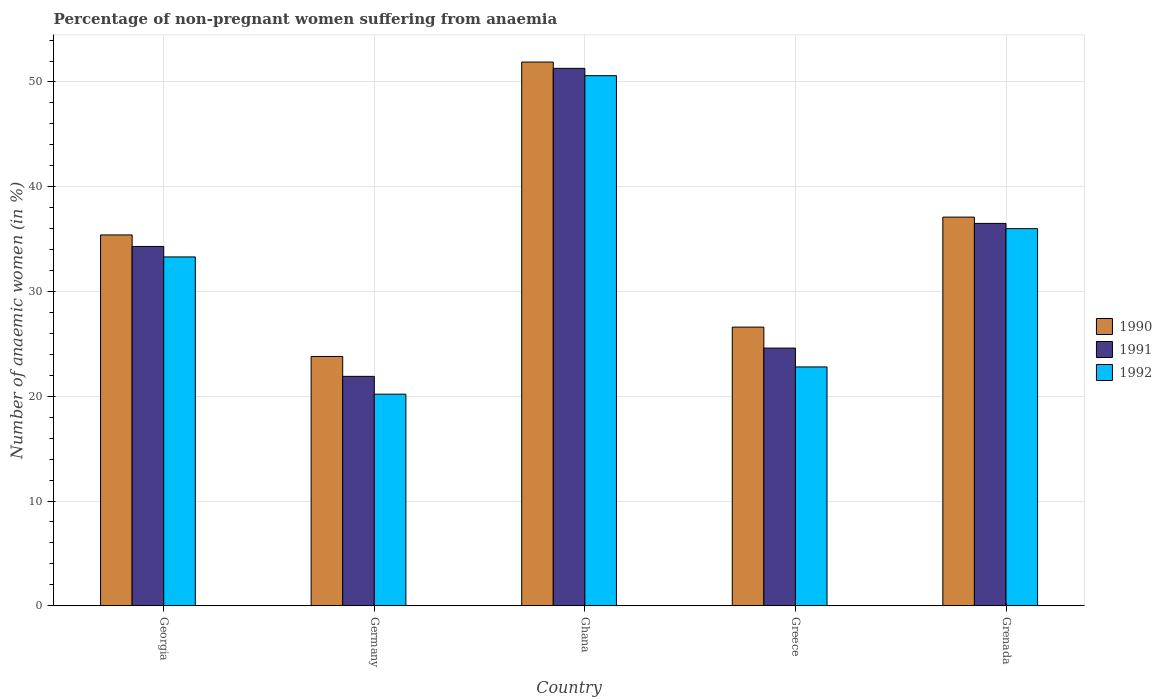How many different coloured bars are there?
Offer a very short reply. 3. How many groups of bars are there?
Your answer should be compact. 5. Are the number of bars on each tick of the X-axis equal?
Ensure brevity in your answer.  Yes. How many bars are there on the 1st tick from the left?
Your response must be concise. 3. How many bars are there on the 2nd tick from the right?
Make the answer very short. 3. In how many cases, is the number of bars for a given country not equal to the number of legend labels?
Your answer should be compact. 0. What is the percentage of non-pregnant women suffering from anaemia in 1991 in Ghana?
Provide a short and direct response. 51.3. Across all countries, what is the maximum percentage of non-pregnant women suffering from anaemia in 1992?
Give a very brief answer. 50.6. Across all countries, what is the minimum percentage of non-pregnant women suffering from anaemia in 1990?
Ensure brevity in your answer.  23.8. In which country was the percentage of non-pregnant women suffering from anaemia in 1991 maximum?
Your answer should be compact. Ghana. In which country was the percentage of non-pregnant women suffering from anaemia in 1992 minimum?
Make the answer very short. Germany. What is the total percentage of non-pregnant women suffering from anaemia in 1992 in the graph?
Your answer should be compact. 162.9. What is the difference between the percentage of non-pregnant women suffering from anaemia in 1992 in Germany and that in Grenada?
Your answer should be very brief. -15.8. What is the difference between the percentage of non-pregnant women suffering from anaemia in 1990 in Georgia and the percentage of non-pregnant women suffering from anaemia in 1992 in Ghana?
Provide a short and direct response. -15.2. What is the average percentage of non-pregnant women suffering from anaemia in 1990 per country?
Provide a short and direct response. 34.96. What is the difference between the percentage of non-pregnant women suffering from anaemia of/in 1991 and percentage of non-pregnant women suffering from anaemia of/in 1992 in Grenada?
Your answer should be compact. 0.5. In how many countries, is the percentage of non-pregnant women suffering from anaemia in 1992 greater than 14 %?
Offer a very short reply. 5. What is the ratio of the percentage of non-pregnant women suffering from anaemia in 1990 in Georgia to that in Grenada?
Your answer should be compact. 0.95. What is the difference between the highest and the second highest percentage of non-pregnant women suffering from anaemia in 1991?
Make the answer very short. -17. What is the difference between the highest and the lowest percentage of non-pregnant women suffering from anaemia in 1990?
Keep it short and to the point. 28.1. In how many countries, is the percentage of non-pregnant women suffering from anaemia in 1992 greater than the average percentage of non-pregnant women suffering from anaemia in 1992 taken over all countries?
Offer a very short reply. 3. Is the sum of the percentage of non-pregnant women suffering from anaemia in 1992 in Georgia and Grenada greater than the maximum percentage of non-pregnant women suffering from anaemia in 1991 across all countries?
Your answer should be very brief. Yes. What does the 2nd bar from the right in Georgia represents?
Your response must be concise. 1991. Are all the bars in the graph horizontal?
Your response must be concise. No. Are the values on the major ticks of Y-axis written in scientific E-notation?
Provide a short and direct response. No. Does the graph contain grids?
Provide a short and direct response. Yes. Where does the legend appear in the graph?
Provide a succinct answer. Center right. How are the legend labels stacked?
Your response must be concise. Vertical. What is the title of the graph?
Your answer should be compact. Percentage of non-pregnant women suffering from anaemia. Does "1965" appear as one of the legend labels in the graph?
Your response must be concise. No. What is the label or title of the X-axis?
Offer a terse response. Country. What is the label or title of the Y-axis?
Make the answer very short. Number of anaemic women (in %). What is the Number of anaemic women (in %) of 1990 in Georgia?
Your response must be concise. 35.4. What is the Number of anaemic women (in %) in 1991 in Georgia?
Offer a very short reply. 34.3. What is the Number of anaemic women (in %) in 1992 in Georgia?
Your answer should be compact. 33.3. What is the Number of anaemic women (in %) of 1990 in Germany?
Make the answer very short. 23.8. What is the Number of anaemic women (in %) of 1991 in Germany?
Your answer should be compact. 21.9. What is the Number of anaemic women (in %) of 1992 in Germany?
Offer a very short reply. 20.2. What is the Number of anaemic women (in %) in 1990 in Ghana?
Keep it short and to the point. 51.9. What is the Number of anaemic women (in %) of 1991 in Ghana?
Ensure brevity in your answer.  51.3. What is the Number of anaemic women (in %) in 1992 in Ghana?
Keep it short and to the point. 50.6. What is the Number of anaemic women (in %) in 1990 in Greece?
Your answer should be compact. 26.6. What is the Number of anaemic women (in %) in 1991 in Greece?
Your answer should be compact. 24.6. What is the Number of anaemic women (in %) of 1992 in Greece?
Offer a terse response. 22.8. What is the Number of anaemic women (in %) of 1990 in Grenada?
Your response must be concise. 37.1. What is the Number of anaemic women (in %) of 1991 in Grenada?
Your response must be concise. 36.5. Across all countries, what is the maximum Number of anaemic women (in %) of 1990?
Your response must be concise. 51.9. Across all countries, what is the maximum Number of anaemic women (in %) of 1991?
Offer a very short reply. 51.3. Across all countries, what is the maximum Number of anaemic women (in %) in 1992?
Your answer should be very brief. 50.6. Across all countries, what is the minimum Number of anaemic women (in %) of 1990?
Your answer should be compact. 23.8. Across all countries, what is the minimum Number of anaemic women (in %) of 1991?
Ensure brevity in your answer.  21.9. Across all countries, what is the minimum Number of anaemic women (in %) in 1992?
Offer a very short reply. 20.2. What is the total Number of anaemic women (in %) of 1990 in the graph?
Make the answer very short. 174.8. What is the total Number of anaemic women (in %) of 1991 in the graph?
Your answer should be very brief. 168.6. What is the total Number of anaemic women (in %) in 1992 in the graph?
Give a very brief answer. 162.9. What is the difference between the Number of anaemic women (in %) of 1991 in Georgia and that in Germany?
Your answer should be compact. 12.4. What is the difference between the Number of anaemic women (in %) of 1992 in Georgia and that in Germany?
Your answer should be very brief. 13.1. What is the difference between the Number of anaemic women (in %) in 1990 in Georgia and that in Ghana?
Provide a short and direct response. -16.5. What is the difference between the Number of anaemic women (in %) in 1992 in Georgia and that in Ghana?
Offer a very short reply. -17.3. What is the difference between the Number of anaemic women (in %) of 1990 in Georgia and that in Greece?
Your response must be concise. 8.8. What is the difference between the Number of anaemic women (in %) in 1991 in Georgia and that in Greece?
Provide a succinct answer. 9.7. What is the difference between the Number of anaemic women (in %) in 1990 in Georgia and that in Grenada?
Keep it short and to the point. -1.7. What is the difference between the Number of anaemic women (in %) in 1990 in Germany and that in Ghana?
Keep it short and to the point. -28.1. What is the difference between the Number of anaemic women (in %) in 1991 in Germany and that in Ghana?
Your answer should be compact. -29.4. What is the difference between the Number of anaemic women (in %) of 1992 in Germany and that in Ghana?
Your answer should be compact. -30.4. What is the difference between the Number of anaemic women (in %) in 1991 in Germany and that in Greece?
Offer a very short reply. -2.7. What is the difference between the Number of anaemic women (in %) of 1991 in Germany and that in Grenada?
Give a very brief answer. -14.6. What is the difference between the Number of anaemic women (in %) in 1992 in Germany and that in Grenada?
Your response must be concise. -15.8. What is the difference between the Number of anaemic women (in %) of 1990 in Ghana and that in Greece?
Offer a very short reply. 25.3. What is the difference between the Number of anaemic women (in %) in 1991 in Ghana and that in Greece?
Offer a very short reply. 26.7. What is the difference between the Number of anaemic women (in %) in 1992 in Ghana and that in Greece?
Offer a very short reply. 27.8. What is the difference between the Number of anaemic women (in %) of 1990 in Ghana and that in Grenada?
Keep it short and to the point. 14.8. What is the difference between the Number of anaemic women (in %) of 1990 in Greece and that in Grenada?
Ensure brevity in your answer.  -10.5. What is the difference between the Number of anaemic women (in %) of 1991 in Greece and that in Grenada?
Give a very brief answer. -11.9. What is the difference between the Number of anaemic women (in %) of 1990 in Georgia and the Number of anaemic women (in %) of 1992 in Germany?
Keep it short and to the point. 15.2. What is the difference between the Number of anaemic women (in %) of 1990 in Georgia and the Number of anaemic women (in %) of 1991 in Ghana?
Your response must be concise. -15.9. What is the difference between the Number of anaemic women (in %) in 1990 in Georgia and the Number of anaemic women (in %) in 1992 in Ghana?
Your answer should be compact. -15.2. What is the difference between the Number of anaemic women (in %) in 1991 in Georgia and the Number of anaemic women (in %) in 1992 in Ghana?
Give a very brief answer. -16.3. What is the difference between the Number of anaemic women (in %) in 1990 in Georgia and the Number of anaemic women (in %) in 1991 in Greece?
Offer a very short reply. 10.8. What is the difference between the Number of anaemic women (in %) of 1991 in Georgia and the Number of anaemic women (in %) of 1992 in Grenada?
Ensure brevity in your answer.  -1.7. What is the difference between the Number of anaemic women (in %) in 1990 in Germany and the Number of anaemic women (in %) in 1991 in Ghana?
Ensure brevity in your answer.  -27.5. What is the difference between the Number of anaemic women (in %) of 1990 in Germany and the Number of anaemic women (in %) of 1992 in Ghana?
Offer a very short reply. -26.8. What is the difference between the Number of anaemic women (in %) of 1991 in Germany and the Number of anaemic women (in %) of 1992 in Ghana?
Your answer should be very brief. -28.7. What is the difference between the Number of anaemic women (in %) in 1990 in Germany and the Number of anaemic women (in %) in 1991 in Grenada?
Provide a short and direct response. -12.7. What is the difference between the Number of anaemic women (in %) of 1991 in Germany and the Number of anaemic women (in %) of 1992 in Grenada?
Your response must be concise. -14.1. What is the difference between the Number of anaemic women (in %) of 1990 in Ghana and the Number of anaemic women (in %) of 1991 in Greece?
Keep it short and to the point. 27.3. What is the difference between the Number of anaemic women (in %) of 1990 in Ghana and the Number of anaemic women (in %) of 1992 in Greece?
Your answer should be very brief. 29.1. What is the difference between the Number of anaemic women (in %) in 1990 in Greece and the Number of anaemic women (in %) in 1991 in Grenada?
Provide a succinct answer. -9.9. What is the difference between the Number of anaemic women (in %) in 1990 in Greece and the Number of anaemic women (in %) in 1992 in Grenada?
Make the answer very short. -9.4. What is the average Number of anaemic women (in %) of 1990 per country?
Give a very brief answer. 34.96. What is the average Number of anaemic women (in %) of 1991 per country?
Your answer should be very brief. 33.72. What is the average Number of anaemic women (in %) of 1992 per country?
Give a very brief answer. 32.58. What is the difference between the Number of anaemic women (in %) of 1990 and Number of anaemic women (in %) of 1991 in Georgia?
Provide a succinct answer. 1.1. What is the difference between the Number of anaemic women (in %) in 1991 and Number of anaemic women (in %) in 1992 in Georgia?
Ensure brevity in your answer.  1. What is the difference between the Number of anaemic women (in %) of 1991 and Number of anaemic women (in %) of 1992 in Germany?
Provide a short and direct response. 1.7. What is the difference between the Number of anaemic women (in %) of 1990 and Number of anaemic women (in %) of 1991 in Ghana?
Your answer should be compact. 0.6. What is the difference between the Number of anaemic women (in %) in 1990 and Number of anaemic women (in %) in 1992 in Ghana?
Offer a terse response. 1.3. What is the difference between the Number of anaemic women (in %) in 1991 and Number of anaemic women (in %) in 1992 in Ghana?
Give a very brief answer. 0.7. What is the difference between the Number of anaemic women (in %) of 1990 and Number of anaemic women (in %) of 1991 in Greece?
Provide a succinct answer. 2. What is the difference between the Number of anaemic women (in %) of 1990 and Number of anaemic women (in %) of 1992 in Greece?
Ensure brevity in your answer.  3.8. What is the difference between the Number of anaemic women (in %) of 1991 and Number of anaemic women (in %) of 1992 in Greece?
Offer a very short reply. 1.8. What is the difference between the Number of anaemic women (in %) in 1990 and Number of anaemic women (in %) in 1991 in Grenada?
Give a very brief answer. 0.6. What is the ratio of the Number of anaemic women (in %) in 1990 in Georgia to that in Germany?
Your answer should be compact. 1.49. What is the ratio of the Number of anaemic women (in %) of 1991 in Georgia to that in Germany?
Make the answer very short. 1.57. What is the ratio of the Number of anaemic women (in %) in 1992 in Georgia to that in Germany?
Give a very brief answer. 1.65. What is the ratio of the Number of anaemic women (in %) of 1990 in Georgia to that in Ghana?
Provide a succinct answer. 0.68. What is the ratio of the Number of anaemic women (in %) in 1991 in Georgia to that in Ghana?
Your answer should be very brief. 0.67. What is the ratio of the Number of anaemic women (in %) in 1992 in Georgia to that in Ghana?
Your response must be concise. 0.66. What is the ratio of the Number of anaemic women (in %) in 1990 in Georgia to that in Greece?
Give a very brief answer. 1.33. What is the ratio of the Number of anaemic women (in %) in 1991 in Georgia to that in Greece?
Your answer should be very brief. 1.39. What is the ratio of the Number of anaemic women (in %) of 1992 in Georgia to that in Greece?
Offer a terse response. 1.46. What is the ratio of the Number of anaemic women (in %) in 1990 in Georgia to that in Grenada?
Ensure brevity in your answer.  0.95. What is the ratio of the Number of anaemic women (in %) in 1991 in Georgia to that in Grenada?
Offer a very short reply. 0.94. What is the ratio of the Number of anaemic women (in %) of 1992 in Georgia to that in Grenada?
Provide a short and direct response. 0.93. What is the ratio of the Number of anaemic women (in %) of 1990 in Germany to that in Ghana?
Your answer should be very brief. 0.46. What is the ratio of the Number of anaemic women (in %) of 1991 in Germany to that in Ghana?
Your response must be concise. 0.43. What is the ratio of the Number of anaemic women (in %) in 1992 in Germany to that in Ghana?
Provide a succinct answer. 0.4. What is the ratio of the Number of anaemic women (in %) in 1990 in Germany to that in Greece?
Your answer should be very brief. 0.89. What is the ratio of the Number of anaemic women (in %) in 1991 in Germany to that in Greece?
Give a very brief answer. 0.89. What is the ratio of the Number of anaemic women (in %) in 1992 in Germany to that in Greece?
Offer a very short reply. 0.89. What is the ratio of the Number of anaemic women (in %) in 1990 in Germany to that in Grenada?
Provide a succinct answer. 0.64. What is the ratio of the Number of anaemic women (in %) of 1991 in Germany to that in Grenada?
Provide a short and direct response. 0.6. What is the ratio of the Number of anaemic women (in %) in 1992 in Germany to that in Grenada?
Make the answer very short. 0.56. What is the ratio of the Number of anaemic women (in %) of 1990 in Ghana to that in Greece?
Your answer should be very brief. 1.95. What is the ratio of the Number of anaemic women (in %) of 1991 in Ghana to that in Greece?
Provide a succinct answer. 2.09. What is the ratio of the Number of anaemic women (in %) of 1992 in Ghana to that in Greece?
Provide a short and direct response. 2.22. What is the ratio of the Number of anaemic women (in %) in 1990 in Ghana to that in Grenada?
Make the answer very short. 1.4. What is the ratio of the Number of anaemic women (in %) in 1991 in Ghana to that in Grenada?
Offer a very short reply. 1.41. What is the ratio of the Number of anaemic women (in %) of 1992 in Ghana to that in Grenada?
Your answer should be compact. 1.41. What is the ratio of the Number of anaemic women (in %) of 1990 in Greece to that in Grenada?
Offer a very short reply. 0.72. What is the ratio of the Number of anaemic women (in %) of 1991 in Greece to that in Grenada?
Your answer should be very brief. 0.67. What is the ratio of the Number of anaemic women (in %) in 1992 in Greece to that in Grenada?
Give a very brief answer. 0.63. What is the difference between the highest and the second highest Number of anaemic women (in %) in 1990?
Your response must be concise. 14.8. What is the difference between the highest and the second highest Number of anaemic women (in %) in 1991?
Provide a succinct answer. 14.8. What is the difference between the highest and the lowest Number of anaemic women (in %) in 1990?
Provide a short and direct response. 28.1. What is the difference between the highest and the lowest Number of anaemic women (in %) of 1991?
Give a very brief answer. 29.4. What is the difference between the highest and the lowest Number of anaemic women (in %) of 1992?
Give a very brief answer. 30.4. 